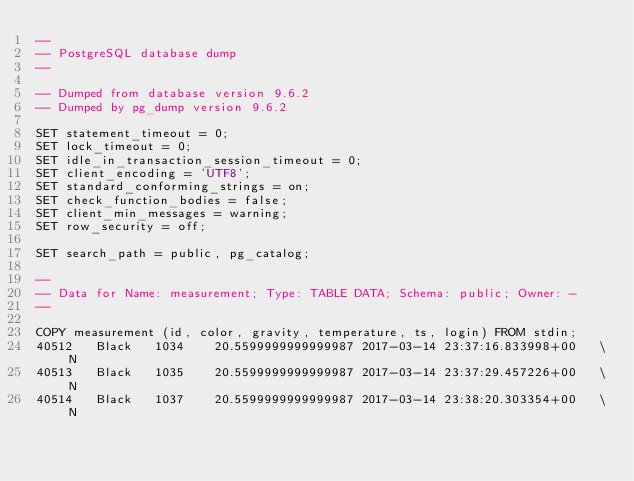<code> <loc_0><loc_0><loc_500><loc_500><_SQL_>--
-- PostgreSQL database dump
--

-- Dumped from database version 9.6.2
-- Dumped by pg_dump version 9.6.2

SET statement_timeout = 0;
SET lock_timeout = 0;
SET idle_in_transaction_session_timeout = 0;
SET client_encoding = 'UTF8';
SET standard_conforming_strings = on;
SET check_function_bodies = false;
SET client_min_messages = warning;
SET row_security = off;

SET search_path = public, pg_catalog;

--
-- Data for Name: measurement; Type: TABLE DATA; Schema: public; Owner: -
--

COPY measurement (id, color, gravity, temperature, ts, login) FROM stdin;
40512	Black	1034	20.5599999999999987	2017-03-14 23:37:16.833998+00	\N
40513	Black	1035	20.5599999999999987	2017-03-14 23:37:29.457226+00	\N
40514	Black	1037	20.5599999999999987	2017-03-14 23:38:20.303354+00	\N</code> 